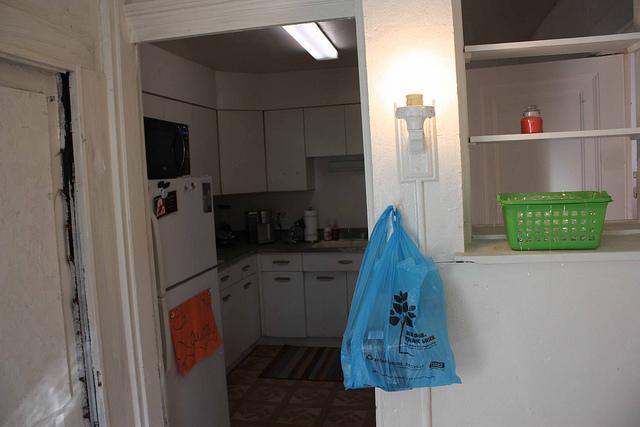What color is the basket?
Be succinct. Green. What is taped to the fridge?
Answer briefly. Picture. What color is predominant in this picture?
Quick response, please. White. 